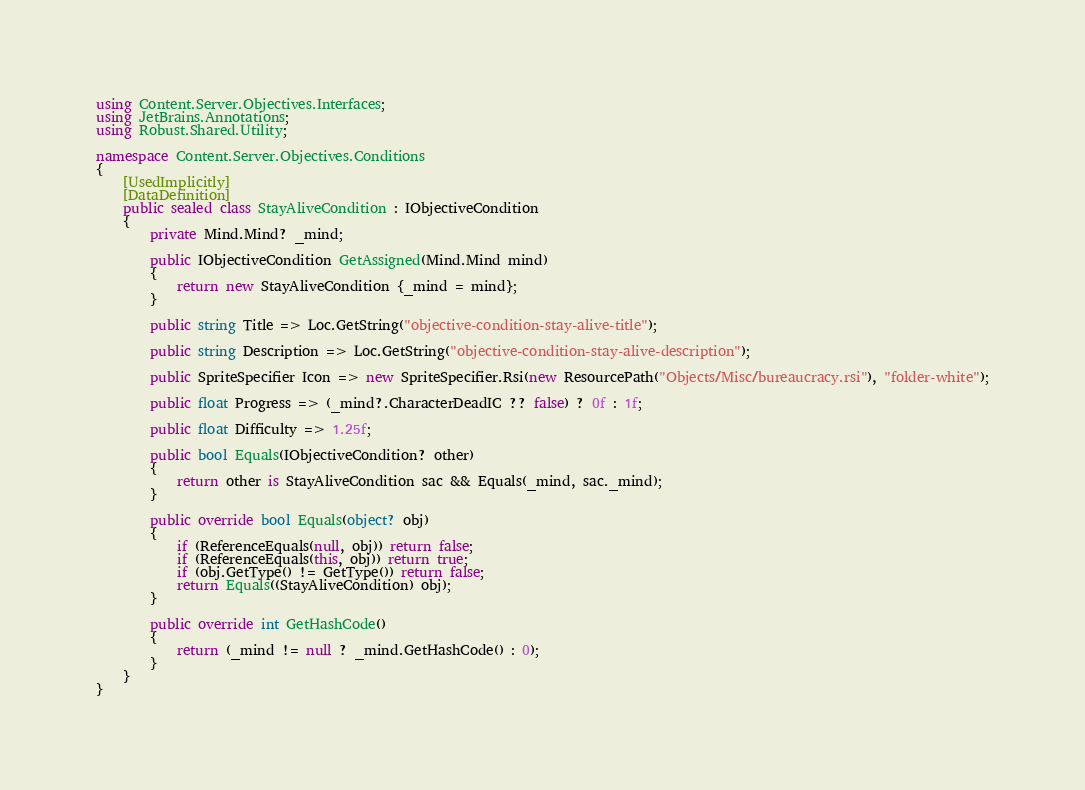<code> <loc_0><loc_0><loc_500><loc_500><_C#_>using Content.Server.Objectives.Interfaces;
using JetBrains.Annotations;
using Robust.Shared.Utility;

namespace Content.Server.Objectives.Conditions
{
    [UsedImplicitly]
    [DataDefinition]
    public sealed class StayAliveCondition : IObjectiveCondition
    {
        private Mind.Mind? _mind;

        public IObjectiveCondition GetAssigned(Mind.Mind mind)
        {
            return new StayAliveCondition {_mind = mind};
        }

        public string Title => Loc.GetString("objective-condition-stay-alive-title");

        public string Description => Loc.GetString("objective-condition-stay-alive-description");

        public SpriteSpecifier Icon => new SpriteSpecifier.Rsi(new ResourcePath("Objects/Misc/bureaucracy.rsi"), "folder-white");

        public float Progress => (_mind?.CharacterDeadIC ?? false) ? 0f : 1f;

        public float Difficulty => 1.25f;

        public bool Equals(IObjectiveCondition? other)
        {
            return other is StayAliveCondition sac && Equals(_mind, sac._mind);
        }

        public override bool Equals(object? obj)
        {
            if (ReferenceEquals(null, obj)) return false;
            if (ReferenceEquals(this, obj)) return true;
            if (obj.GetType() != GetType()) return false;
            return Equals((StayAliveCondition) obj);
        }

        public override int GetHashCode()
        {
            return (_mind != null ? _mind.GetHashCode() : 0);
        }
    }
}
</code> 